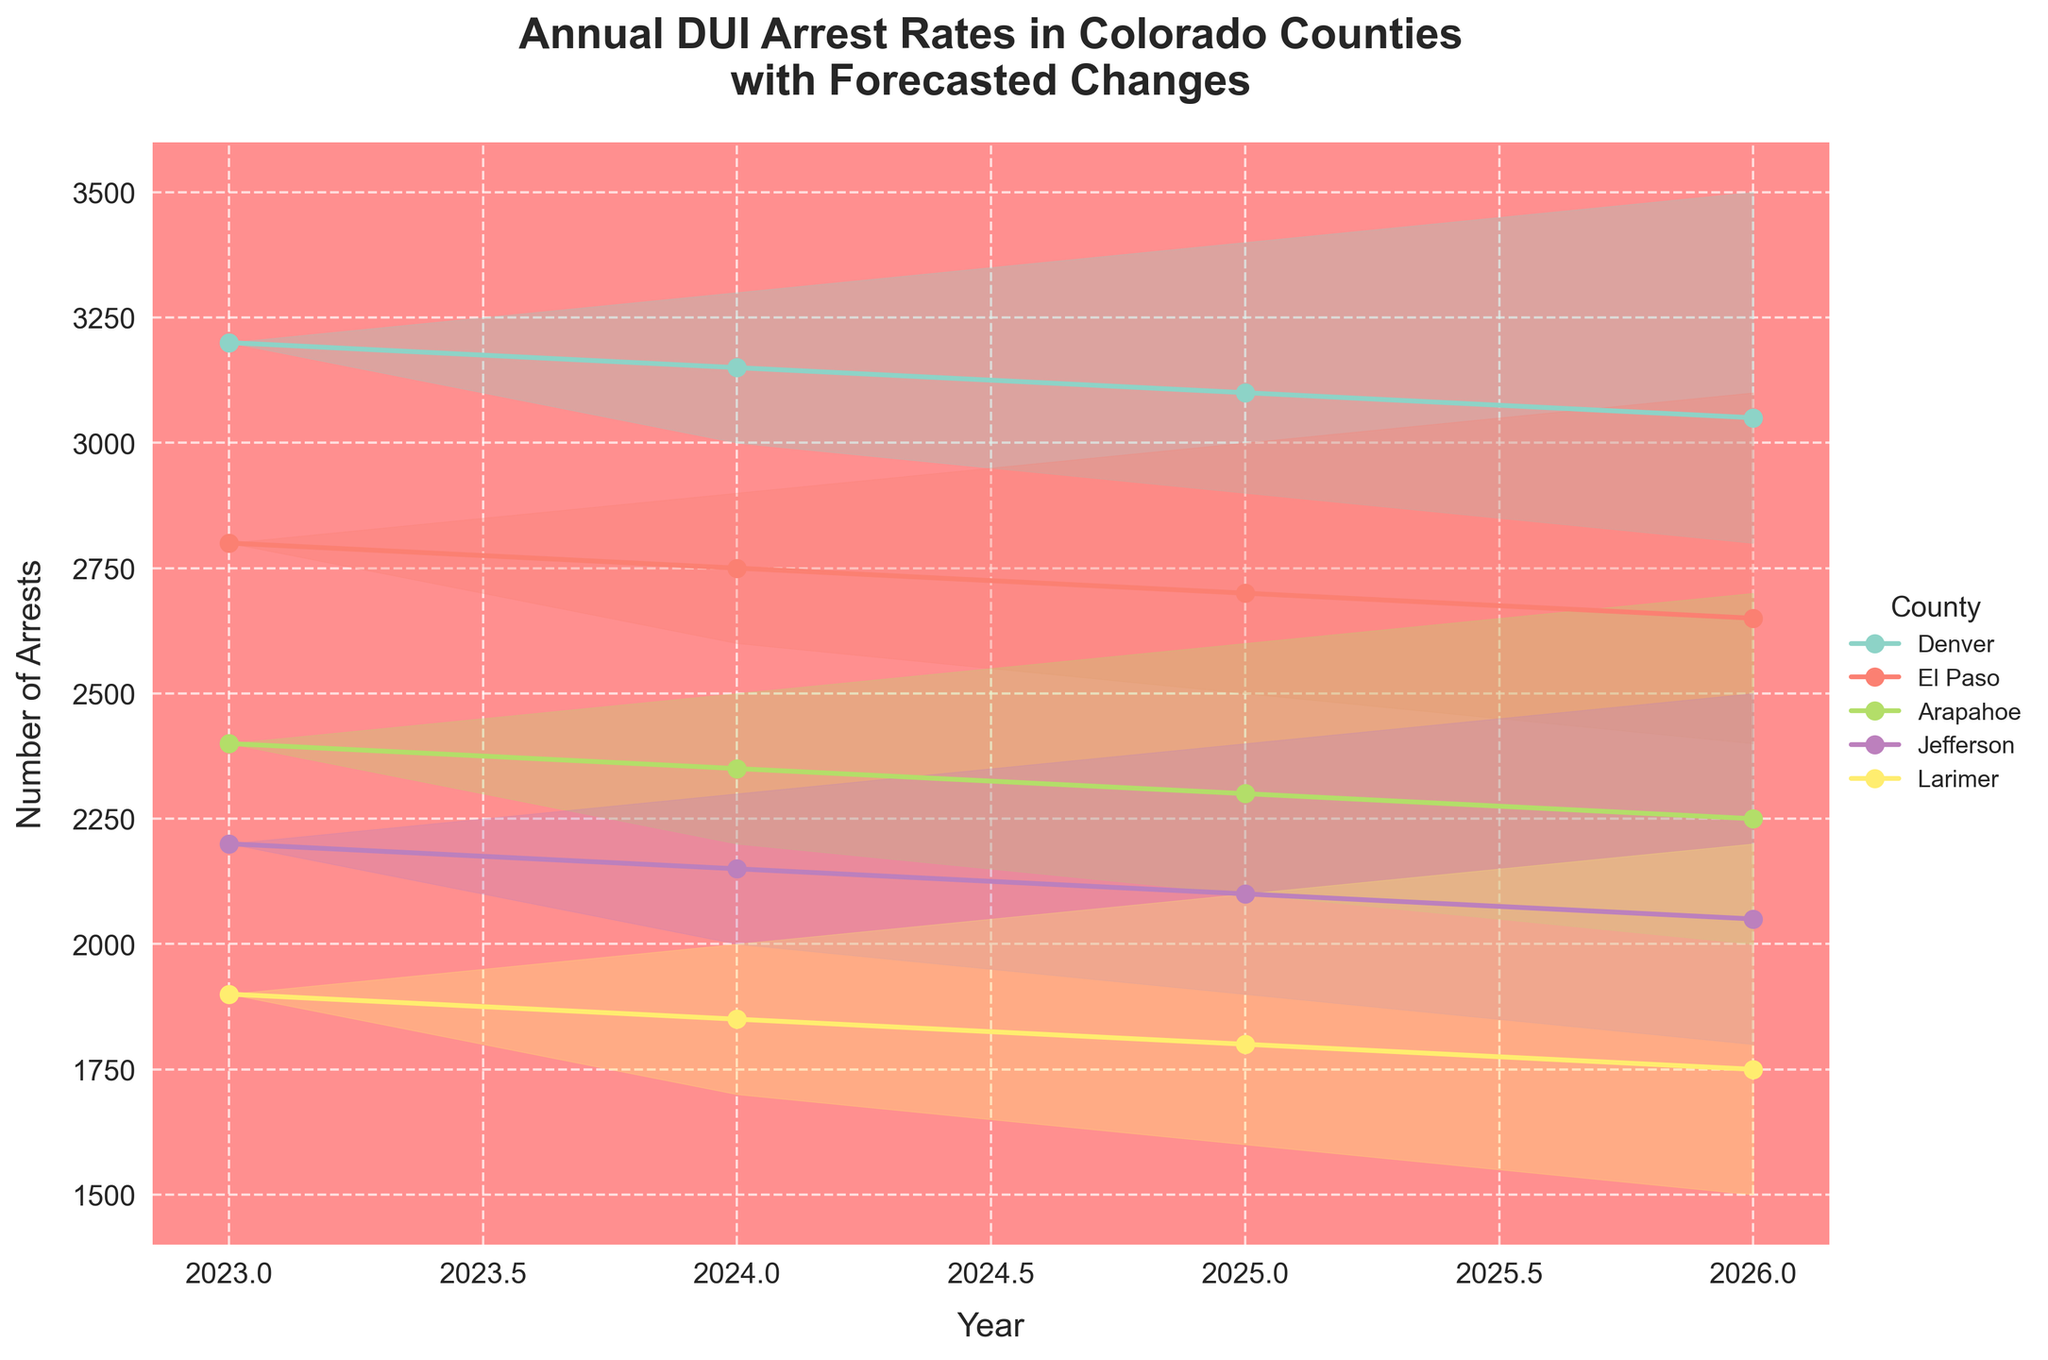How many years are shown in the chart? By counting the number of points along the x-axis, we can determine that the chart shows data from 2023 to 2026.
Answer: 4 Which county has the highest DUI arrest rate in 2023? By examining the plots for the year 2023, we can see that Denver has the highest number of DUI arrests with 3200 arrests.
Answer: Denver What is the forecasted range of DUI arrests for Arapahoe County in 2025? By looking at Arapahoe County's data point for 2025, we see that the lower bound is 2100 and the upper bound is 2600.
Answer: 2100-2600 Which county shows the greatest decrease in DUI arrests from 2023 to 2026? We must calculate the difference between the 2023 and 2026 arrest rates for each county. Denver: 3200-3050=150, El Paso: 2800-2650=150, Arapahoe: 2400-2250=150, Jefferson: 2200-2050=150, Larimer: 1900-1750=150. Each county shows an equal decrease of 150 arrests.
Answer: All counties decrease by 150 How does the uncertainty in DUI arrest forecasts change over time for Larimer County? The range of forecasts for Larimer County widens over time. In 2024, it's 1700 to 2000, and by 2026, it's 1500 to 2200, indicating increasing uncertainty.
Answer: Increases over time Which county has the narrowest forecast range in 2026? By comparing the 2026 ranges, Denver (2800-3500=700), El Paso (2400-3100=700), Arapahoe (2000-2700=700), Jefferson (1800-2500=700), Larimer (1500-2200=700). All counties have an equal forecast range of 700.
Answer: All counties have equal range What is the average forecast range for Jefferson County from 2024 to 2026? Calculate the range for each year (2024: 2300-2000=300, 2025: 2400-1900=500, 2026: 2500-1800=700), then average: (300+500+700)/3.
Answer: 500 How many counties are presented in the chart? By counting the unique entries in the legend, we can see there are five counties presented: Denver, El Paso, Arapahoe, Jefferson, and Larimer.
Answer: 5 Which county is expected to have the smallest number of DUI arrests in 2026? By examining the downward trend lines, we see that Larimer County has the lowest number of expected DUI arrests in 2026.
Answer: Larimer 